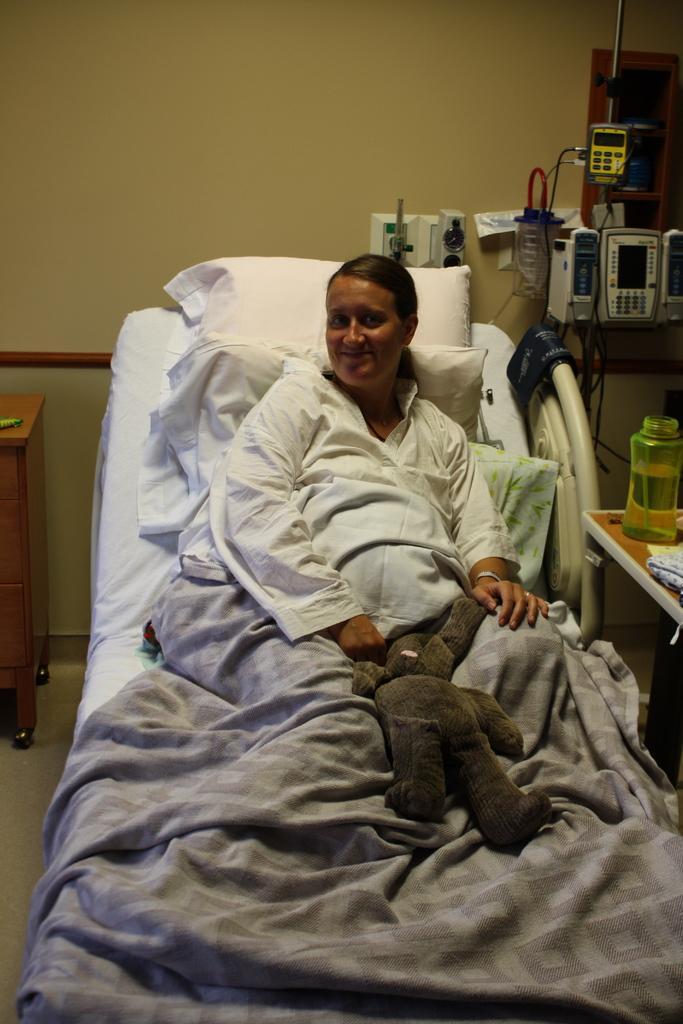Could you give a brief overview of what you see in this image? In the center of the image we can see one woman sitting on the bed. And she is smiling and she is in different costume. And we can see one blanket on her. And we can see one doll on the blanket. In the background there is a wall, tables, one water bottle, machines and a few other objects. 